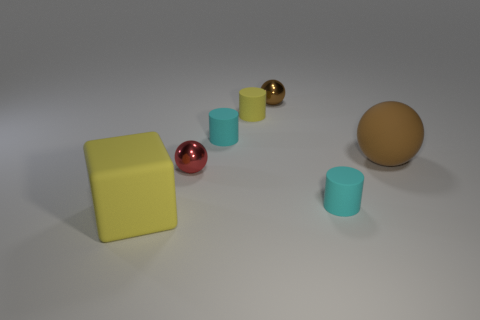Are the large object that is on the right side of the red shiny object and the small cyan thing that is left of the tiny brown ball made of the same material?
Offer a very short reply. Yes. What number of other objects are the same size as the brown matte sphere?
Give a very brief answer. 1. What number of things are either brown matte things or large matte objects right of the block?
Your response must be concise. 1. Are there the same number of big yellow objects on the left side of the large sphere and large brown balls?
Ensure brevity in your answer.  Yes. There is a brown thing that is made of the same material as the yellow cylinder; what is its shape?
Keep it short and to the point. Sphere. Is there a big rubber cylinder that has the same color as the cube?
Keep it short and to the point. No. What number of shiny things are large cubes or brown spheres?
Give a very brief answer. 1. How many red objects are behind the small metal ball behind the yellow cylinder?
Provide a succinct answer. 0. Are there an equal number of small balls and red objects?
Ensure brevity in your answer.  No. How many other objects have the same material as the large brown object?
Ensure brevity in your answer.  4. 